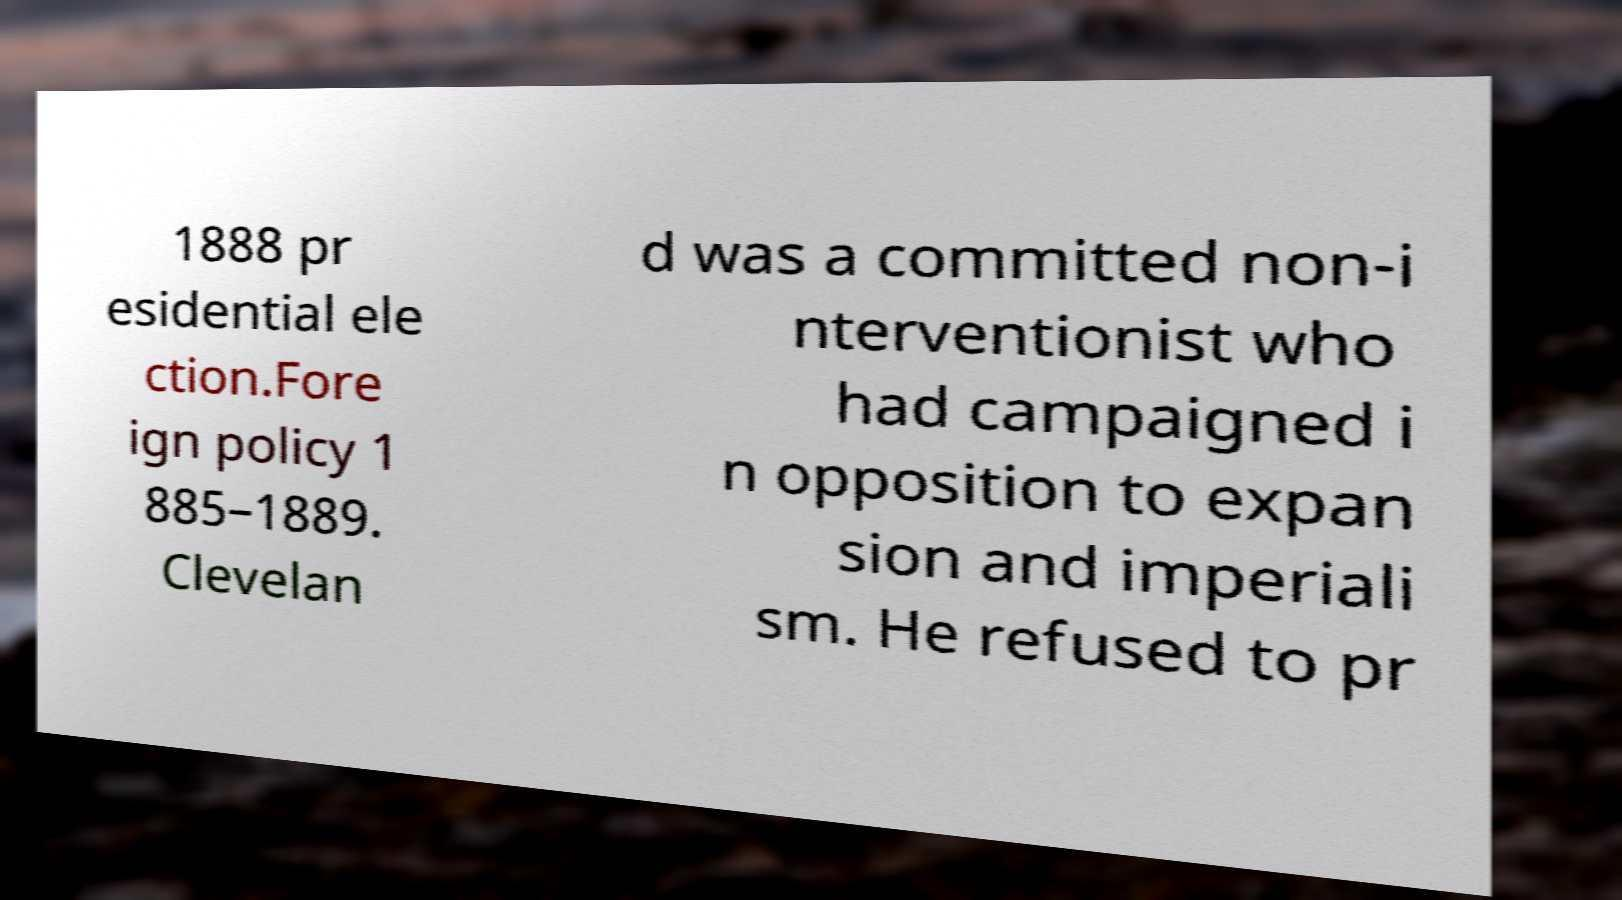Please read and relay the text visible in this image. What does it say? 1888 pr esidential ele ction.Fore ign policy 1 885–1889. Clevelan d was a committed non-i nterventionist who had campaigned i n opposition to expan sion and imperiali sm. He refused to pr 